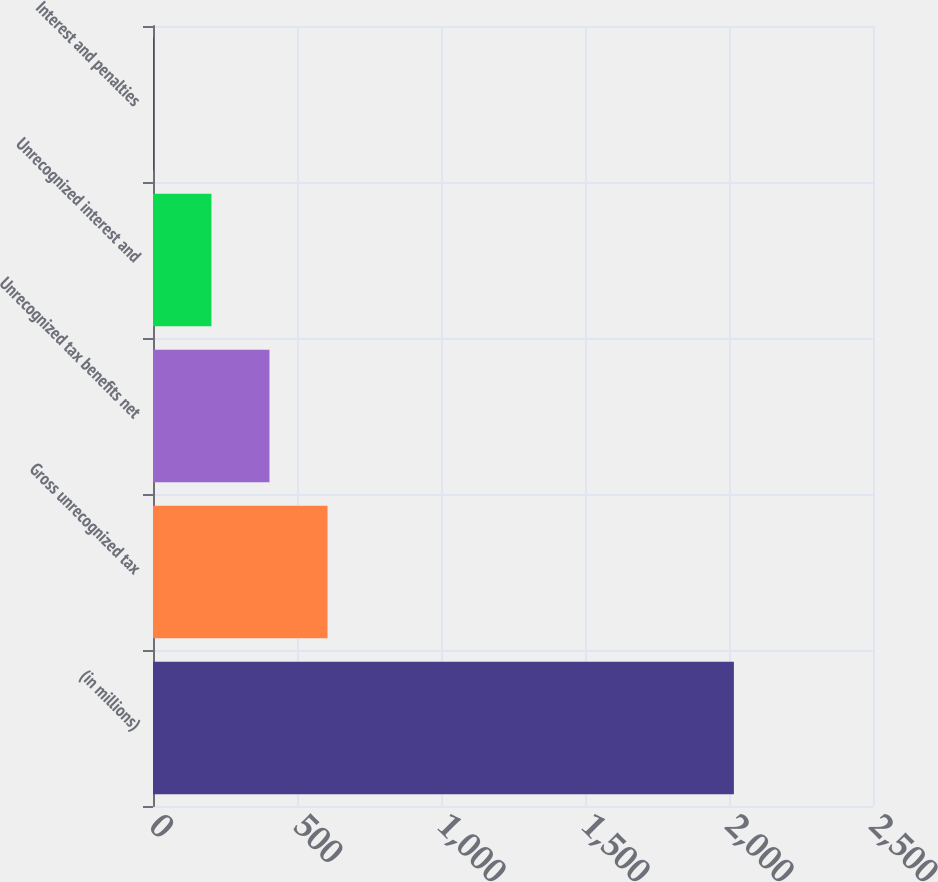Convert chart to OTSL. <chart><loc_0><loc_0><loc_500><loc_500><bar_chart><fcel>(in millions)<fcel>Gross unrecognized tax<fcel>Unrecognized tax benefits net<fcel>Unrecognized interest and<fcel>Interest and penalties<nl><fcel>2017<fcel>606.01<fcel>404.44<fcel>202.87<fcel>1.3<nl></chart> 